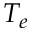Convert formula to latex. <formula><loc_0><loc_0><loc_500><loc_500>T _ { e }</formula> 